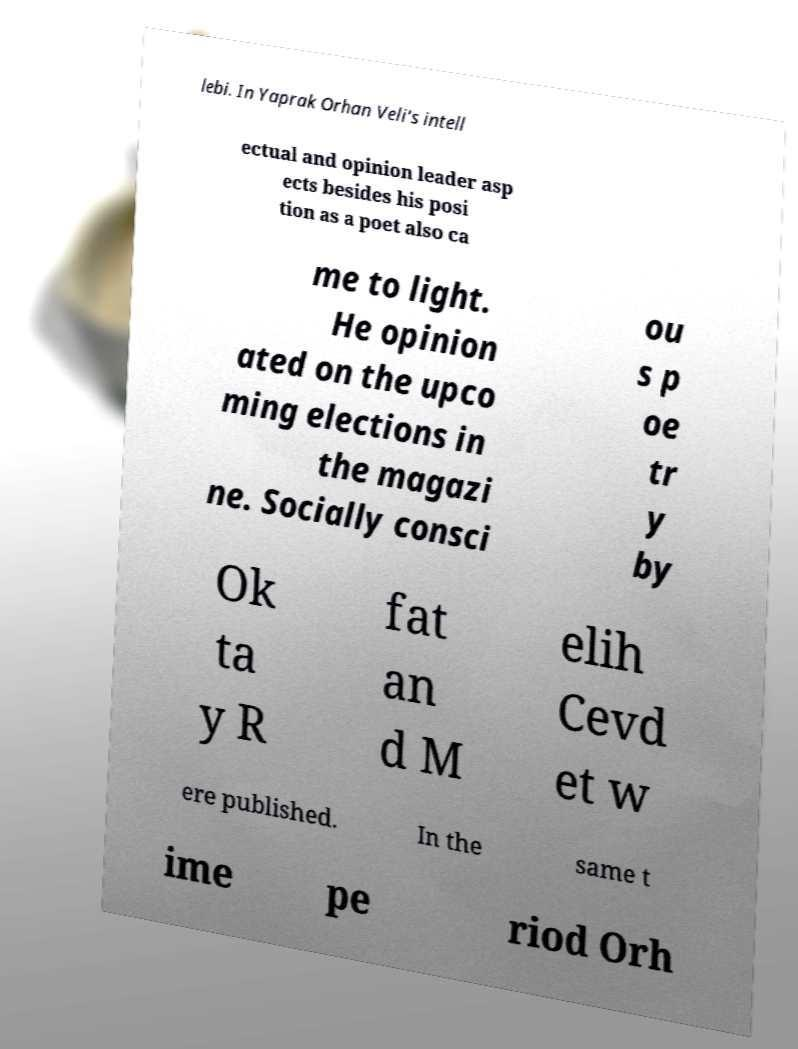Could you extract and type out the text from this image? lebi. In Yaprak Orhan Veli's intell ectual and opinion leader asp ects besides his posi tion as a poet also ca me to light. He opinion ated on the upco ming elections in the magazi ne. Socially consci ou s p oe tr y by Ok ta y R fat an d M elih Cevd et w ere published. In the same t ime pe riod Orh 